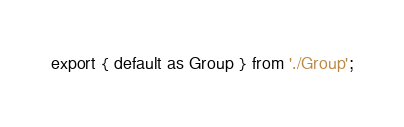Convert code to text. <code><loc_0><loc_0><loc_500><loc_500><_TypeScript_>export { default as Group } from './Group';
</code> 